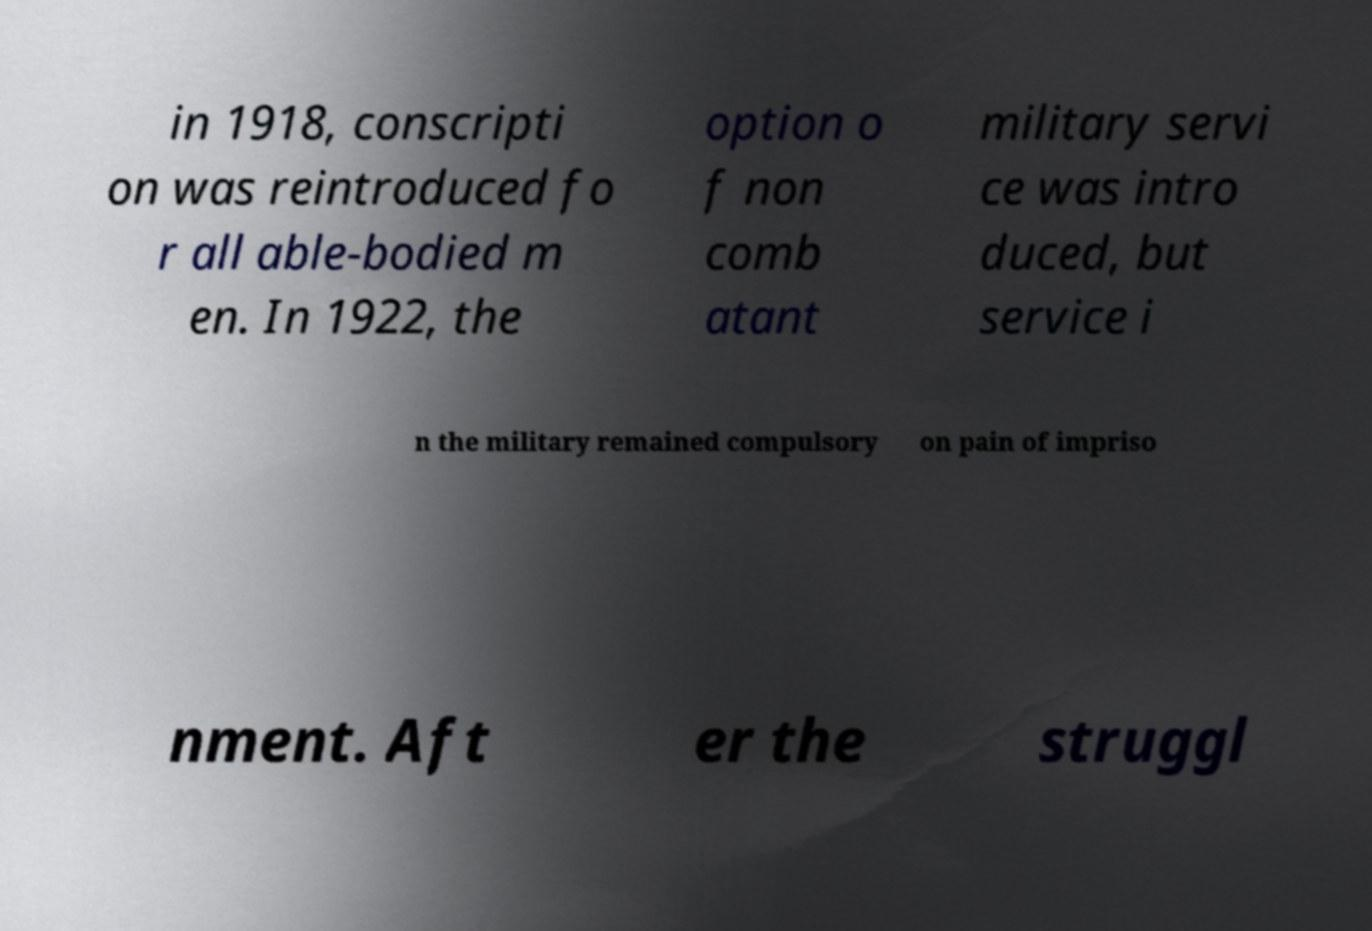For documentation purposes, I need the text within this image transcribed. Could you provide that? in 1918, conscripti on was reintroduced fo r all able-bodied m en. In 1922, the option o f non comb atant military servi ce was intro duced, but service i n the military remained compulsory on pain of impriso nment. Aft er the struggl 